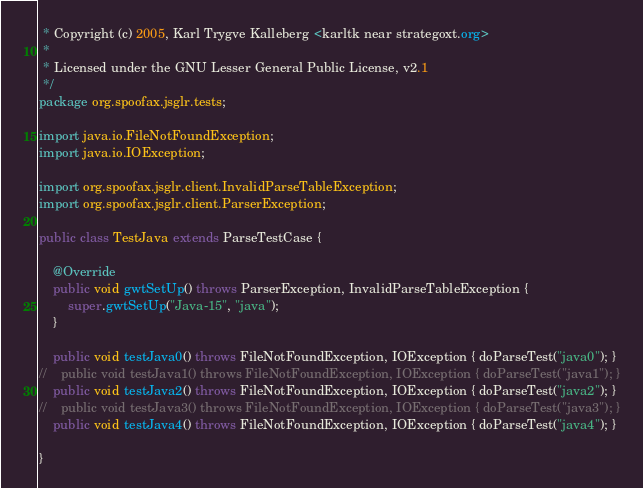<code> <loc_0><loc_0><loc_500><loc_500><_Java_> * Copyright (c) 2005, Karl Trygve Kalleberg <karltk near strategoxt.org>
 *
 * Licensed under the GNU Lesser General Public License, v2.1
 */
package org.spoofax.jsglr.tests;

import java.io.FileNotFoundException;
import java.io.IOException;

import org.spoofax.jsglr.client.InvalidParseTableException;
import org.spoofax.jsglr.client.ParserException;

public class TestJava extends ParseTestCase {

    @Override
	public void gwtSetUp() throws ParserException, InvalidParseTableException {
        super.gwtSetUp("Java-15", "java");
    }

    public void testJava0() throws FileNotFoundException, IOException { doParseTest("java0"); }
//    public void testJava1() throws FileNotFoundException, IOException { doParseTest("java1"); }
    public void testJava2() throws FileNotFoundException, IOException { doParseTest("java2"); }
//    public void testJava3() throws FileNotFoundException, IOException { doParseTest("java3"); }
    public void testJava4() throws FileNotFoundException, IOException { doParseTest("java4"); }
    
}
</code> 